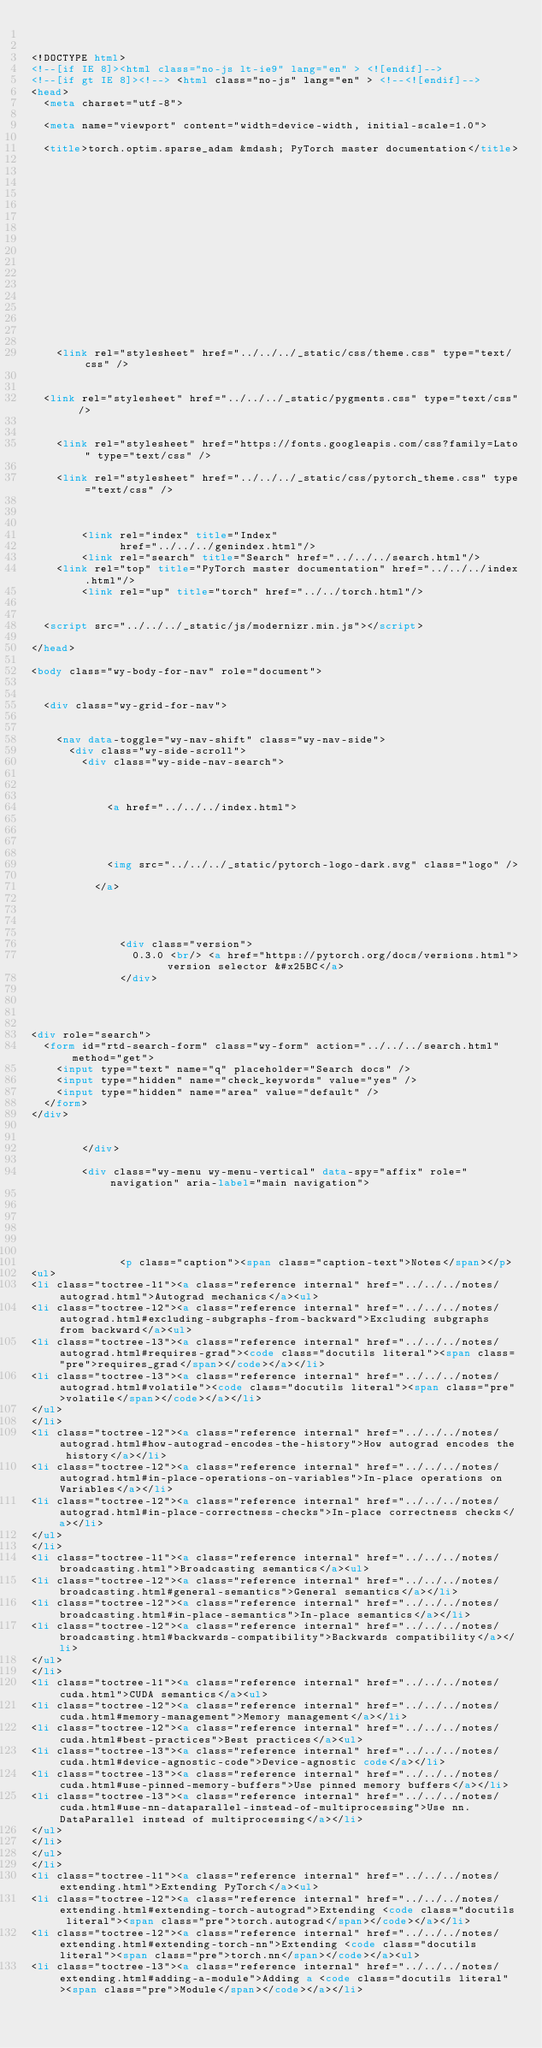Convert code to text. <code><loc_0><loc_0><loc_500><loc_500><_HTML_>

<!DOCTYPE html>
<!--[if IE 8]><html class="no-js lt-ie9" lang="en" > <![endif]-->
<!--[if gt IE 8]><!--> <html class="no-js" lang="en" > <!--<![endif]-->
<head>
  <meta charset="utf-8">
  
  <meta name="viewport" content="width=device-width, initial-scale=1.0">
  
  <title>torch.optim.sparse_adam &mdash; PyTorch master documentation</title>
  

  
  
  
  

  

  
  
    

  

  
  
    <link rel="stylesheet" href="../../../_static/css/theme.css" type="text/css" />
  
  
  <link rel="stylesheet" href="../../../_static/pygments.css" type="text/css" />
  
  
    <link rel="stylesheet" href="https://fonts.googleapis.com/css?family=Lato" type="text/css" />
  
    <link rel="stylesheet" href="../../../_static/css/pytorch_theme.css" type="text/css" />
  

  
        <link rel="index" title="Index"
              href="../../../genindex.html"/>
        <link rel="search" title="Search" href="../../../search.html"/>
    <link rel="top" title="PyTorch master documentation" href="../../../index.html"/>
        <link rel="up" title="torch" href="../../torch.html"/> 

  
  <script src="../../../_static/js/modernizr.min.js"></script>

</head>

<body class="wy-body-for-nav" role="document">

   
  <div class="wy-grid-for-nav">

    
    <nav data-toggle="wy-nav-shift" class="wy-nav-side">
      <div class="wy-side-scroll">
        <div class="wy-side-nav-search">
          

          
            <a href="../../../index.html">
          

          
            
            <img src="../../../_static/pytorch-logo-dark.svg" class="logo" />
          
          </a>

          
            
            
              <div class="version">
                0.3.0 <br/> <a href="https://pytorch.org/docs/versions.html"> version selector &#x25BC</a>
              </div>
            
          

          
<div role="search">
  <form id="rtd-search-form" class="wy-form" action="../../../search.html" method="get">
    <input type="text" name="q" placeholder="Search docs" />
    <input type="hidden" name="check_keywords" value="yes" />
    <input type="hidden" name="area" value="default" />
  </form>
</div>

          
        </div>

        <div class="wy-menu wy-menu-vertical" data-spy="affix" role="navigation" aria-label="main navigation">
          
            
            
              
            
            
              <p class="caption"><span class="caption-text">Notes</span></p>
<ul>
<li class="toctree-l1"><a class="reference internal" href="../../../notes/autograd.html">Autograd mechanics</a><ul>
<li class="toctree-l2"><a class="reference internal" href="../../../notes/autograd.html#excluding-subgraphs-from-backward">Excluding subgraphs from backward</a><ul>
<li class="toctree-l3"><a class="reference internal" href="../../../notes/autograd.html#requires-grad"><code class="docutils literal"><span class="pre">requires_grad</span></code></a></li>
<li class="toctree-l3"><a class="reference internal" href="../../../notes/autograd.html#volatile"><code class="docutils literal"><span class="pre">volatile</span></code></a></li>
</ul>
</li>
<li class="toctree-l2"><a class="reference internal" href="../../../notes/autograd.html#how-autograd-encodes-the-history">How autograd encodes the history</a></li>
<li class="toctree-l2"><a class="reference internal" href="../../../notes/autograd.html#in-place-operations-on-variables">In-place operations on Variables</a></li>
<li class="toctree-l2"><a class="reference internal" href="../../../notes/autograd.html#in-place-correctness-checks">In-place correctness checks</a></li>
</ul>
</li>
<li class="toctree-l1"><a class="reference internal" href="../../../notes/broadcasting.html">Broadcasting semantics</a><ul>
<li class="toctree-l2"><a class="reference internal" href="../../../notes/broadcasting.html#general-semantics">General semantics</a></li>
<li class="toctree-l2"><a class="reference internal" href="../../../notes/broadcasting.html#in-place-semantics">In-place semantics</a></li>
<li class="toctree-l2"><a class="reference internal" href="../../../notes/broadcasting.html#backwards-compatibility">Backwards compatibility</a></li>
</ul>
</li>
<li class="toctree-l1"><a class="reference internal" href="../../../notes/cuda.html">CUDA semantics</a><ul>
<li class="toctree-l2"><a class="reference internal" href="../../../notes/cuda.html#memory-management">Memory management</a></li>
<li class="toctree-l2"><a class="reference internal" href="../../../notes/cuda.html#best-practices">Best practices</a><ul>
<li class="toctree-l3"><a class="reference internal" href="../../../notes/cuda.html#device-agnostic-code">Device-agnostic code</a></li>
<li class="toctree-l3"><a class="reference internal" href="../../../notes/cuda.html#use-pinned-memory-buffers">Use pinned memory buffers</a></li>
<li class="toctree-l3"><a class="reference internal" href="../../../notes/cuda.html#use-nn-dataparallel-instead-of-multiprocessing">Use nn.DataParallel instead of multiprocessing</a></li>
</ul>
</li>
</ul>
</li>
<li class="toctree-l1"><a class="reference internal" href="../../../notes/extending.html">Extending PyTorch</a><ul>
<li class="toctree-l2"><a class="reference internal" href="../../../notes/extending.html#extending-torch-autograd">Extending <code class="docutils literal"><span class="pre">torch.autograd</span></code></a></li>
<li class="toctree-l2"><a class="reference internal" href="../../../notes/extending.html#extending-torch-nn">Extending <code class="docutils literal"><span class="pre">torch.nn</span></code></a><ul>
<li class="toctree-l3"><a class="reference internal" href="../../../notes/extending.html#adding-a-module">Adding a <code class="docutils literal"><span class="pre">Module</span></code></a></li></code> 